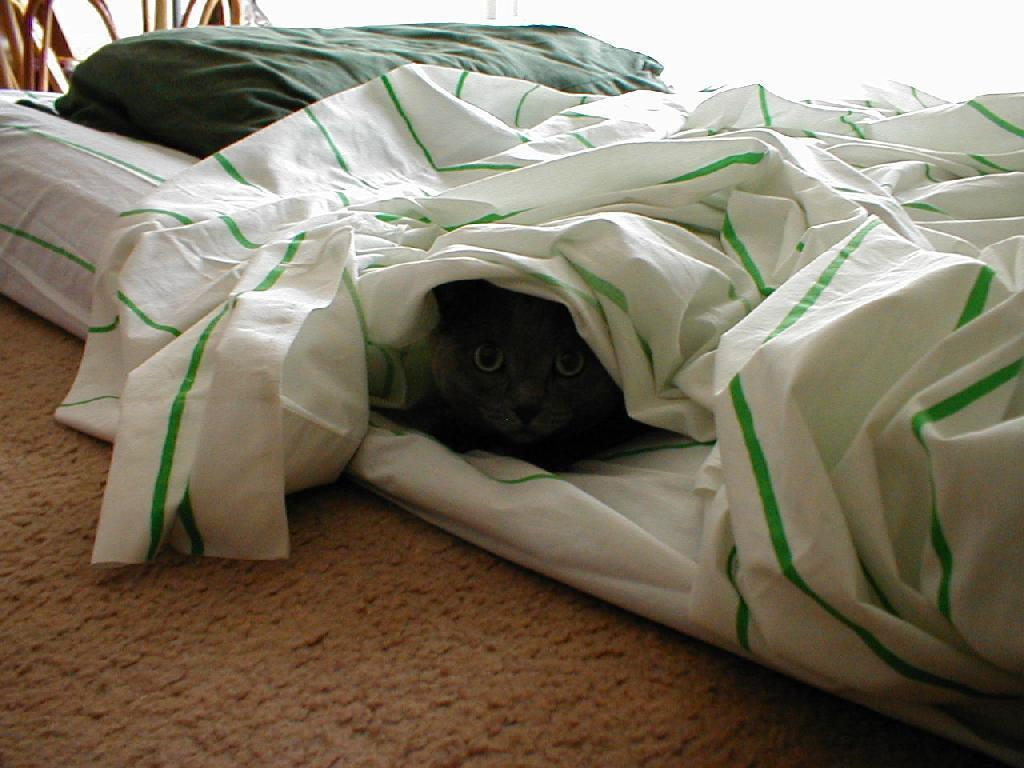What type of animal is in the image? There is a cat in the image. Where is the cat located? The cat is lying on the bed. What is covering the cat? The cat is covered with a blanket. How does the cat sort the laundry in the image? The cat is not sorting laundry in the image; it is lying on the bed covered with a blanket. 